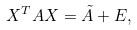<formula> <loc_0><loc_0><loc_500><loc_500>X ^ { T } A X = \tilde { A } + E ,</formula> 